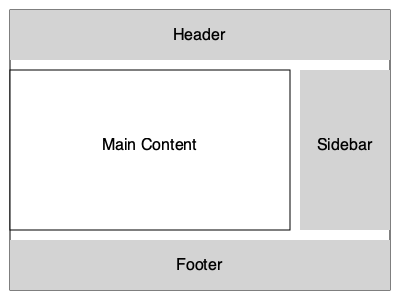Based on the webpage layout diagram shown above, which HTML structure would best represent this layout? To determine the correct HTML structure for this layout, let's analyze the diagram step-by-step:

1. The entire layout is contained within a rectangle, suggesting a main container element.
2. There are four distinct sections: Header, Main Content, Sidebar, and Footer.
3. The Main Content and Sidebar are positioned side by side, indicating they should be grouped together.

Given these observations, the most appropriate HTML structure would be:

1. A `<div>` or `<main>` element as the main container.
2. Inside the main container:
   a. A `<header>` element for the top section.
   b. A `<div>` or `<section>` to group the Main Content and Sidebar.
      - Inside this group:
        - An `<article>` or `<section>` for the Main Content.
        - An `<aside>` for the Sidebar.
   c. A `<footer>` element for the bottom section.

This structure follows semantic HTML principles and accurately represents the visual layout of the webpage.
Answer: <main>
  <header></header>
  <div>
    <article></article>
    <aside></aside>
  </div>
  <footer></footer>
</main> 